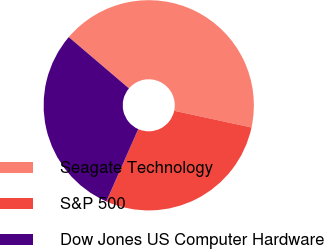Convert chart. <chart><loc_0><loc_0><loc_500><loc_500><pie_chart><fcel>Seagate Technology<fcel>S&P 500<fcel>Dow Jones US Computer Hardware<nl><fcel>42.15%<fcel>28.23%<fcel>29.62%<nl></chart> 